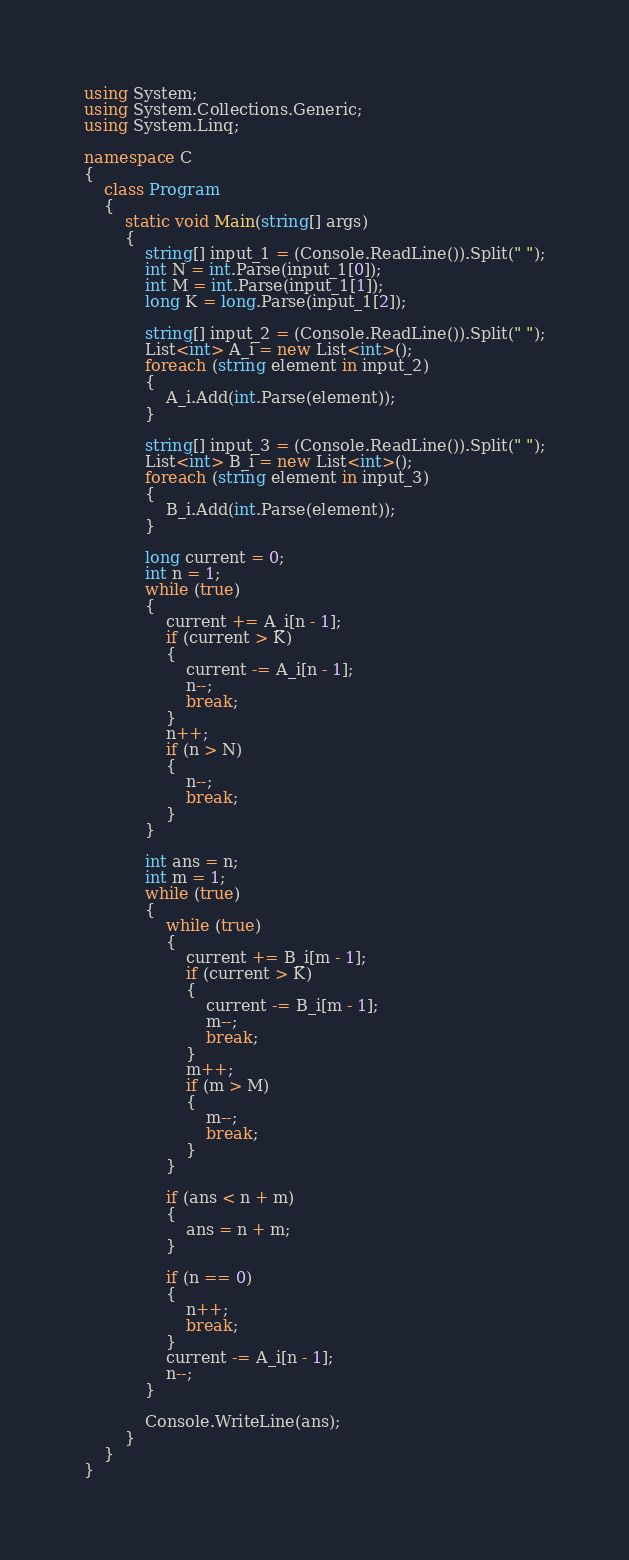<code> <loc_0><loc_0><loc_500><loc_500><_C#_>using System;
using System.Collections.Generic;
using System.Linq;

namespace C
{
    class Program
    {
        static void Main(string[] args)
        {
            string[] input_1 = (Console.ReadLine()).Split(" ");
            int N = int.Parse(input_1[0]);
            int M = int.Parse(input_1[1]);
            long K = long.Parse(input_1[2]);

            string[] input_2 = (Console.ReadLine()).Split(" ");
            List<int> A_i = new List<int>();
            foreach (string element in input_2)
            {
                A_i.Add(int.Parse(element));
            }

            string[] input_3 = (Console.ReadLine()).Split(" ");
            List<int> B_i = new List<int>();
            foreach (string element in input_3)
            {
                B_i.Add(int.Parse(element));
            }

            long current = 0;
            int n = 1;
            while (true)
            {
                current += A_i[n - 1];
                if (current > K)
                {
                    current -= A_i[n - 1];
                    n--;
                    break;
                }
                n++;
                if (n > N)
                {
                    n--;
                    break;
                }
            }

            int ans = n;
            int m = 1;
            while (true)
            {
                while (true)
                {
                    current += B_i[m - 1];
                    if (current > K)
                    {
                        current -= B_i[m - 1];
                        m--;
                        break;
                    }
                    m++;
                    if (m > M)
                    {
                        m--;
                        break;
                    }
                }

                if (ans < n + m)
                {
                    ans = n + m;
                }

                if (n == 0)
                {
                    n++;
                    break;
                }
                current -= A_i[n - 1];
                n--;
            }

            Console.WriteLine(ans);
        }
    }
}
</code> 